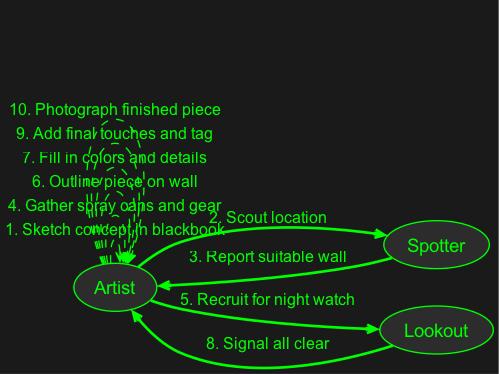What is the first action performed by the Artist? The first action in the sequence diagram is initiated by the Artist who sketches the concept in their blackbook. This is indicated as the very first step in the process.
Answer: Sketch concept in blackbook Which actor is involved in scouting the location? The Spotter is responsible for scouting the location. They follow the action initiated by the Artist seeking a suitable wall for the graffiti.
Answer: Spotter How many total steps are there in the process? The sequence consists of a total of 10 steps, which includes actions taken by the Artist, Spotter, and Lookout methods in creating the graffiti masterpiece.
Answer: 10 What is the last action that the Artist performs? The last action performed by the Artist is to photograph the finished piece. This is the final step in the sequence after completing the artwork.
Answer: Photograph finished piece Which action comes immediately after the Lookout signals all clear? After the Lookout signals all clear, the Artist then proceeds to add final touches and tag the artwork. This action directly follows the signal indicating it's safe to continue.
Answer: Add final touches and tag 